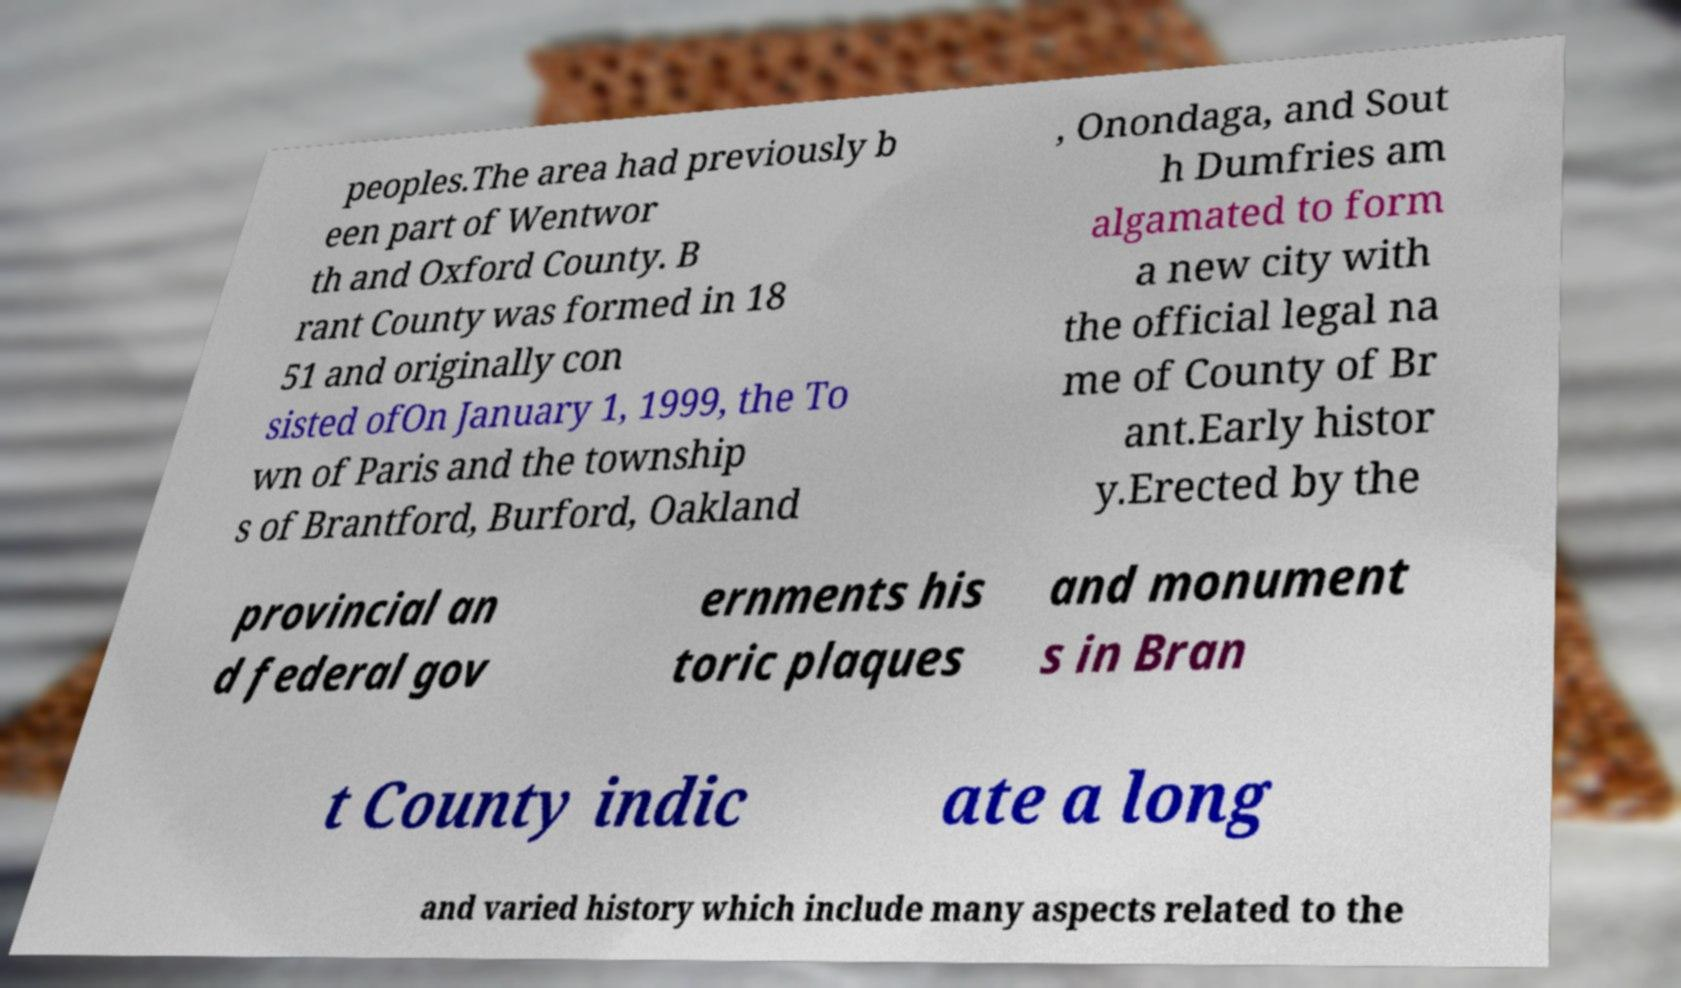I need the written content from this picture converted into text. Can you do that? peoples.The area had previously b een part of Wentwor th and Oxford County. B rant County was formed in 18 51 and originally con sisted ofOn January 1, 1999, the To wn of Paris and the township s of Brantford, Burford, Oakland , Onondaga, and Sout h Dumfries am algamated to form a new city with the official legal na me of County of Br ant.Early histor y.Erected by the provincial an d federal gov ernments his toric plaques and monument s in Bran t County indic ate a long and varied history which include many aspects related to the 